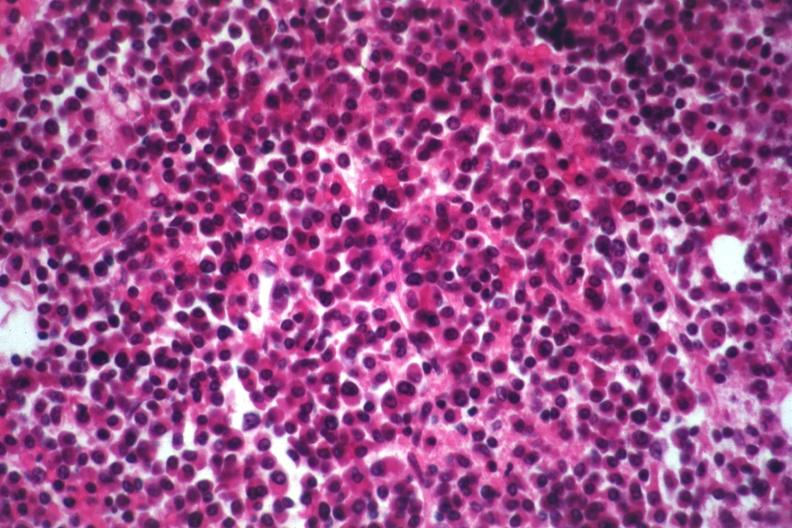what is present?
Answer the question using a single word or phrase. Multiple myeloma 